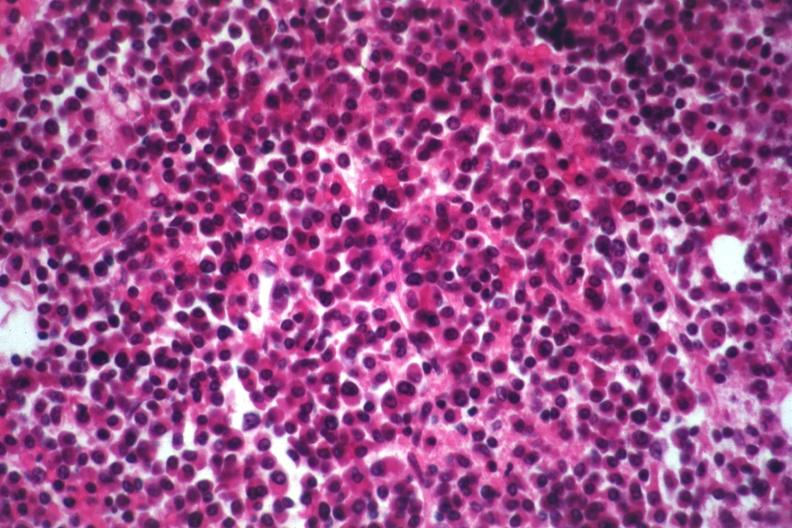what is present?
Answer the question using a single word or phrase. Multiple myeloma 